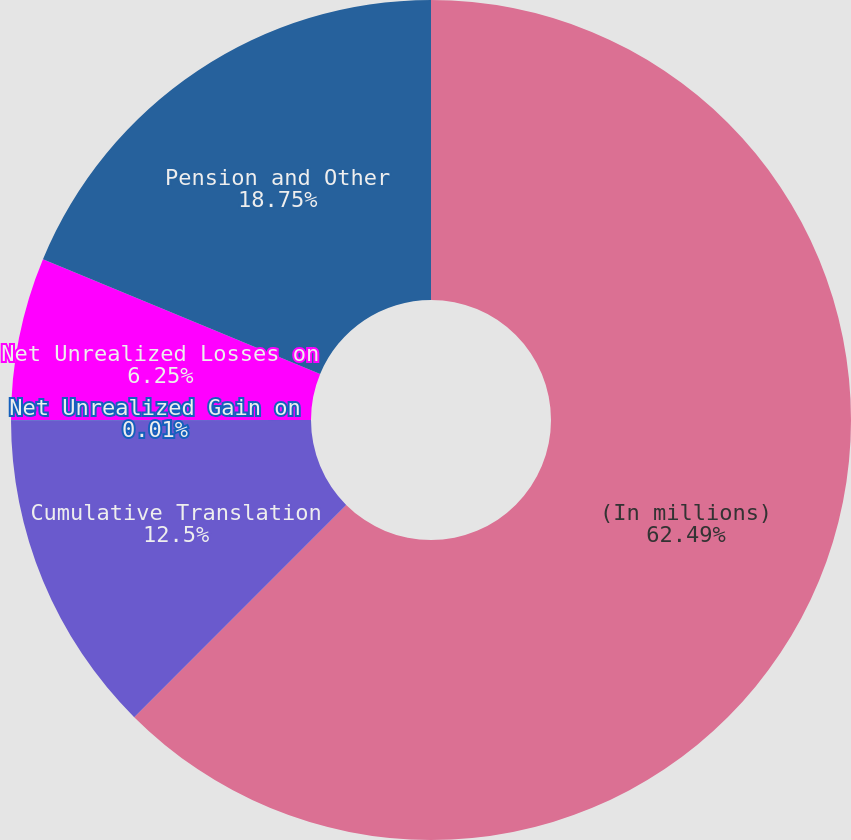<chart> <loc_0><loc_0><loc_500><loc_500><pie_chart><fcel>(In millions)<fcel>Cumulative Translation<fcel>Net Unrealized Gain on<fcel>Net Unrealized Losses on<fcel>Pension and Other<nl><fcel>62.49%<fcel>12.5%<fcel>0.01%<fcel>6.25%<fcel>18.75%<nl></chart> 